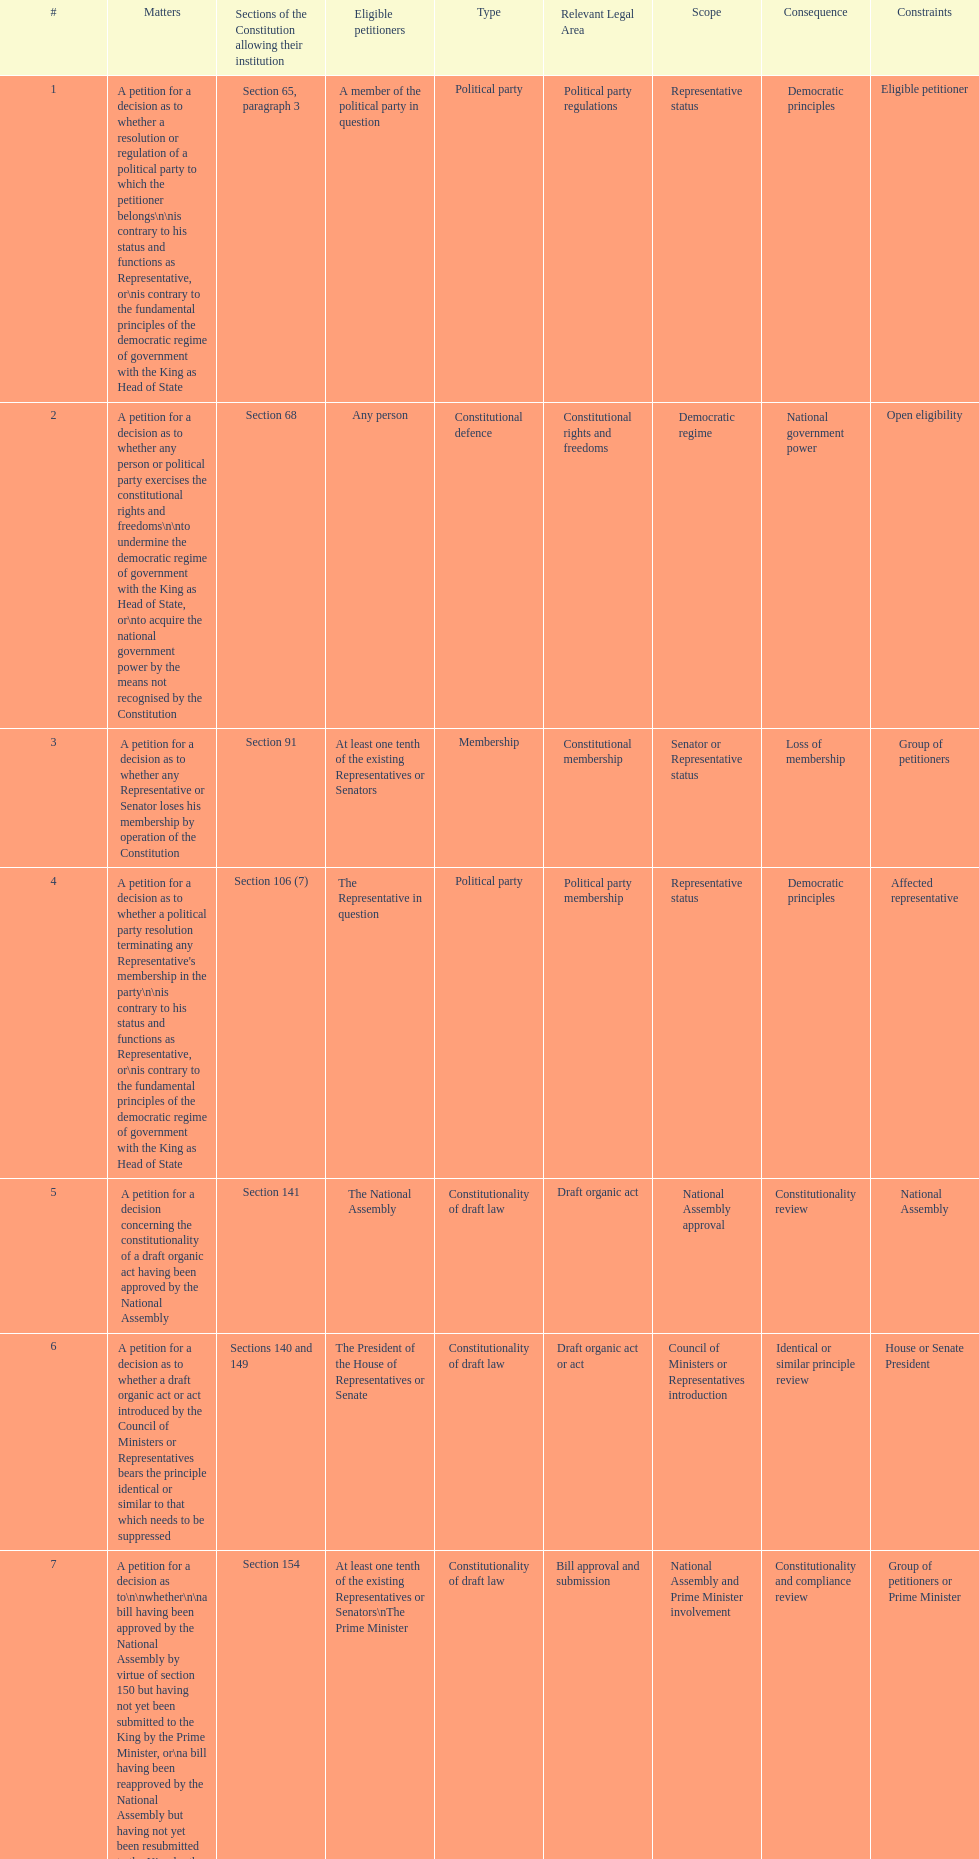How many matters require at least one tenth of the existing representatives or senators? 7. 